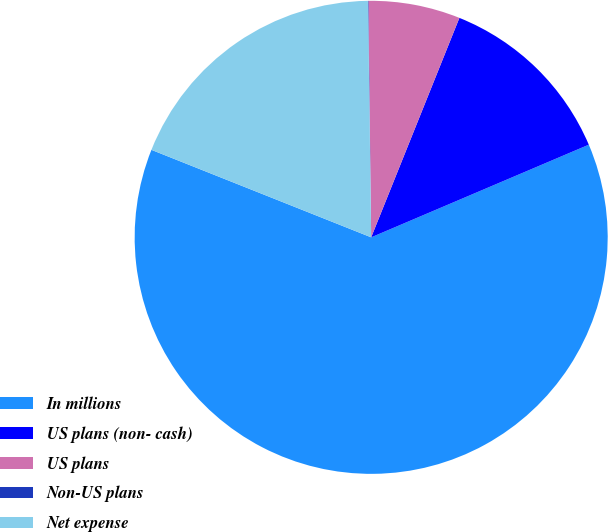Convert chart. <chart><loc_0><loc_0><loc_500><loc_500><pie_chart><fcel>In millions<fcel>US plans (non- cash)<fcel>US plans<fcel>Non-US plans<fcel>Net expense<nl><fcel>62.43%<fcel>12.51%<fcel>6.27%<fcel>0.03%<fcel>18.75%<nl></chart> 